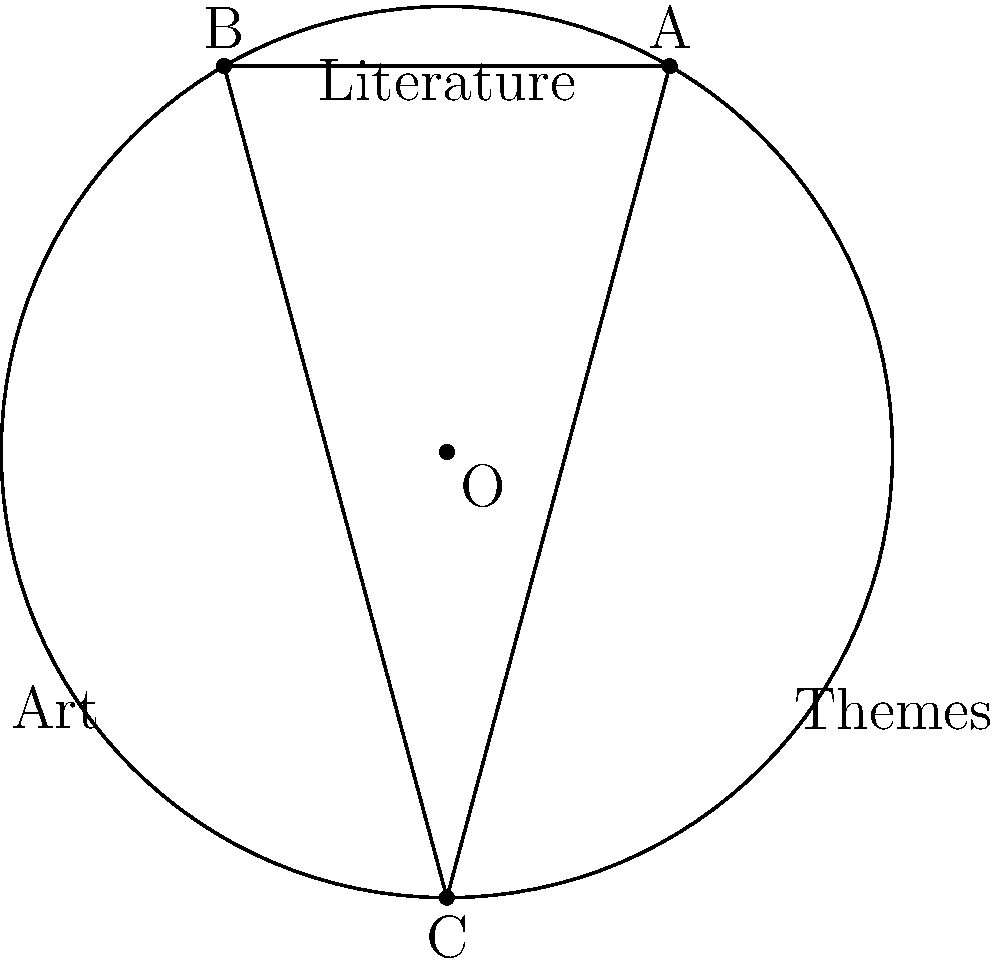In your latest exhibition on the intersection of literature and art, you've designed a circular diagram to represent overlapping themes. The circle has a radius of 4 units, and an equilateral triangle is inscribed within it. Calculate the area of the circular segment outside one side of the triangle, representing unique themes in literature that don't directly overlap with art. Round your answer to two decimal places. Let's approach this step-by-step:

1) First, we need to find the side length of the equilateral triangle. In an equilateral triangle inscribed in a circle, the side length $s$ is related to the radius $r$ by the formula:

   $s = r\sqrt{3}$

2) Substituting $r = 4$:
   
   $s = 4\sqrt{3} \approx 6.93$ units

3) The area of the circular segment is the difference between the area of the sector and the area of the triangle formed by two radii and the chord.

4) The central angle of the sector is 60° (1/6 of the circle). The area of the sector is:

   $A_{sector} = \frac{1}{6} \pi r^2 = \frac{1}{6} \pi (4)^2 = \frac{8}{3} \pi \approx 8.38$ square units

5) The area of the triangle is:

   $A_{triangle} = \frac{1}{2} \cdot 4 \cdot 4 \sin 60° = 4 \cdot \frac{\sqrt{3}}{2} = 2\sqrt{3} \approx 3.46$ square units

6) The area of the segment is:

   $A_{segment} = A_{sector} - A_{triangle} = \frac{8}{3} \pi - 2\sqrt{3} \approx 4.92$ square units

7) Rounding to two decimal places: 4.92 square units.
Answer: 4.92 square units 